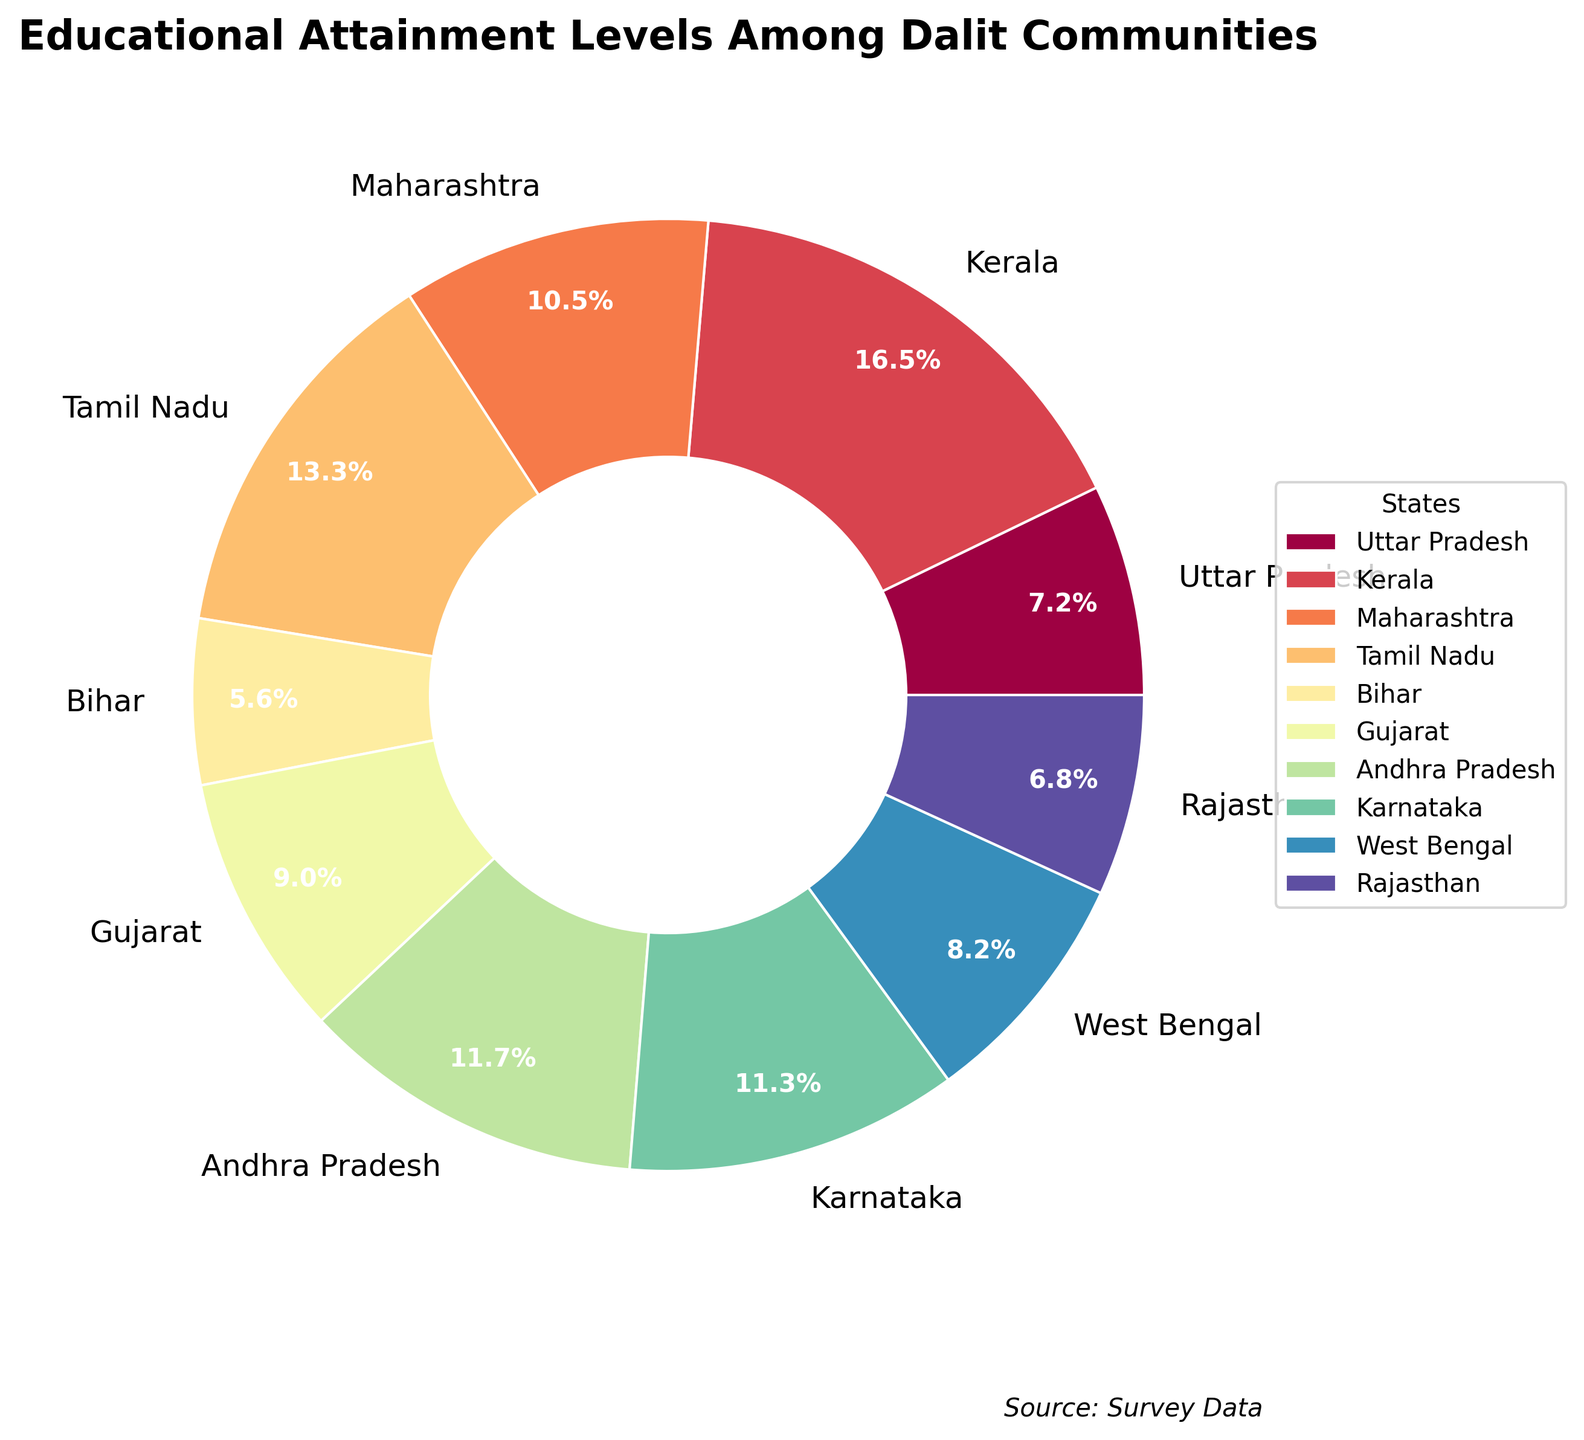Which state has the highest percentage of Dalits with higher education? Look at the pie chart and identify the state with the largest slice. Kerala has the highest percentage with 28.7%.
Answer: Kerala How much higher is the percentage of Dalits with higher education in Tamil Nadu compared to Bihar? Subtract the percentage of Bihar from Tamil Nadu. Tamil Nadu has 23.1% while Bihar has 9.8%, so the difference is 23.1 - 9.8.
Answer: 13.3% What is the combined percentage of Dalits with higher education in Karnataka and Andhra Pradesh? Add the percentages for Karnataka and Andhra Pradesh. Karnataka has 19.7% and Andhra Pradesh has 20.4%. Combined, they make 19.7 + 20.4.
Answer: 40.1% Which state has a lower percentage of Dalits with higher education, Gujarat or West Bengal? Compare the slices representing Gujarat and West Bengal. Gujarat has 15.6% and West Bengal has 14.2%. West Bengal is lower.
Answer: West Bengal Among Uttar Pradesh, Bihar, and Rajasthan, which state has the median percentage of Dalits with higher education? Order the percentages of Uttar Pradesh (12.5%), Bihar (9.8%), and Rajasthan (11.9%) and find the median. The order is 9.8%, 11.9%, 12.5%. The median is 11.9%.
Answer: Rajasthan What is the average percentage of Dalits with higher education among the states listed? Sum the percentages of all states and divide by the number of states. The sum is 12.5 + 28.7 + 18.3 + 23.1 + 9.8 + 15.6 + 20.4 + 19.7 + 14.2 + 11.9 = 174.2. There are 10 states, so 174.2 / 10.
Answer: 17.42% Which state has a percentage most closely matching the average percentage of all states? Calculate the average percentage which is 17.42%, and compare each state's percentage to find the closest match. Maharashtra has 18.3%, which is closest to 17.42%.
Answer: Maharashtra What is the difference in the percentage of Dalits with higher education between Kerala and Maharashtra? Subtract the percentage for Maharashtra from that for Kerala. Kerala has 28.7% and Maharashtra has 18.3%, so 28.7 - 18.3.
Answer: 10.4% Which state has the smallest slice in the pie chart? Identify the smallest slice on the pie chart. Bihar has the smallest slice with 9.8%.
Answer: Bihar If you grouped all states with less than 15% together, what would their combined percentage be? Add the percentages of states below 15%: Uttar Pradesh (12.5%), Bihar (9.8%), West Bengal (14.2%), and Rajasthan (11.9%). Combined, they make 12.5 + 9.8 + 14.2 + 11.9.
Answer: 48.4% 